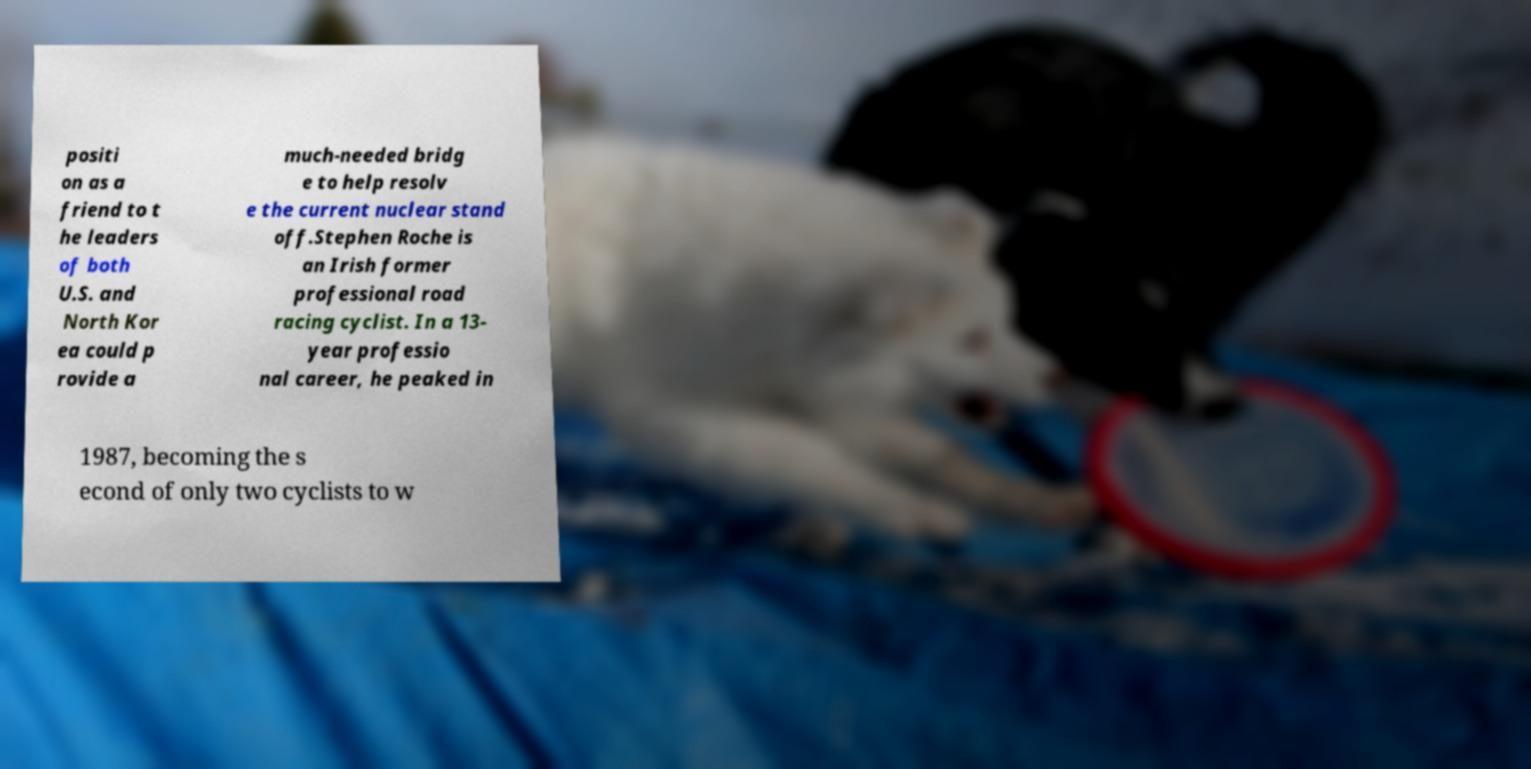For documentation purposes, I need the text within this image transcribed. Could you provide that? positi on as a friend to t he leaders of both U.S. and North Kor ea could p rovide a much-needed bridg e to help resolv e the current nuclear stand off.Stephen Roche is an Irish former professional road racing cyclist. In a 13- year professio nal career, he peaked in 1987, becoming the s econd of only two cyclists to w 